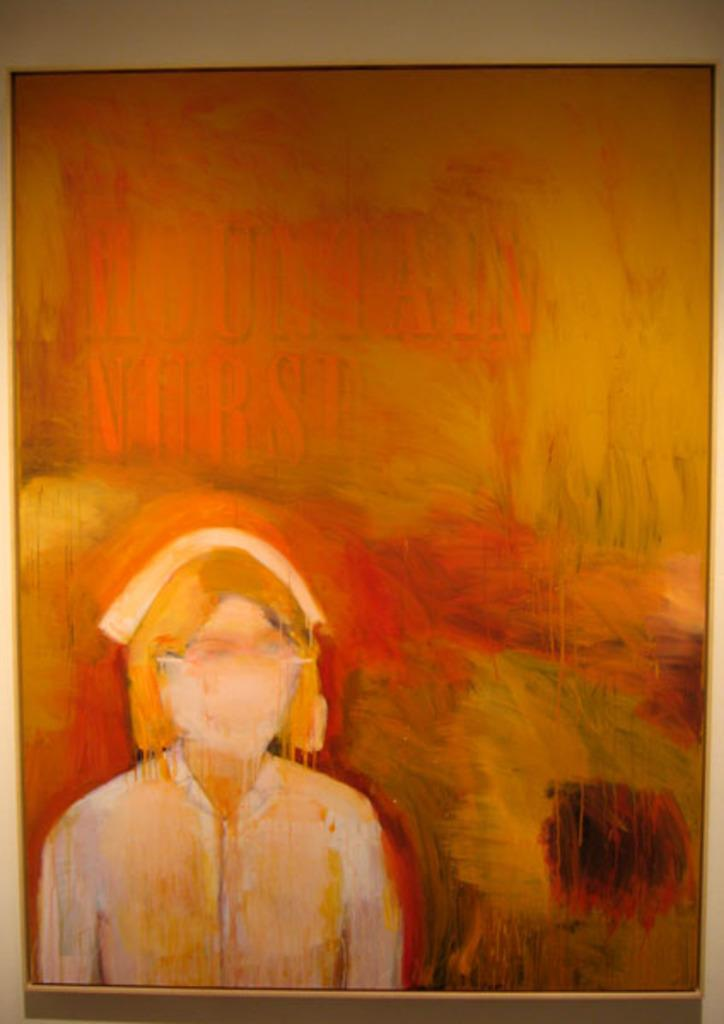What is the main subject of the image? There is a painting in the image. What type of laborer can be seen working on the painting in the image? There is no laborer present in the image, as it only features a painting. How many wrens are depicted in the painting in the image? There is no information about the content of the painting, so it cannot be determined if any wrens are depicted. 